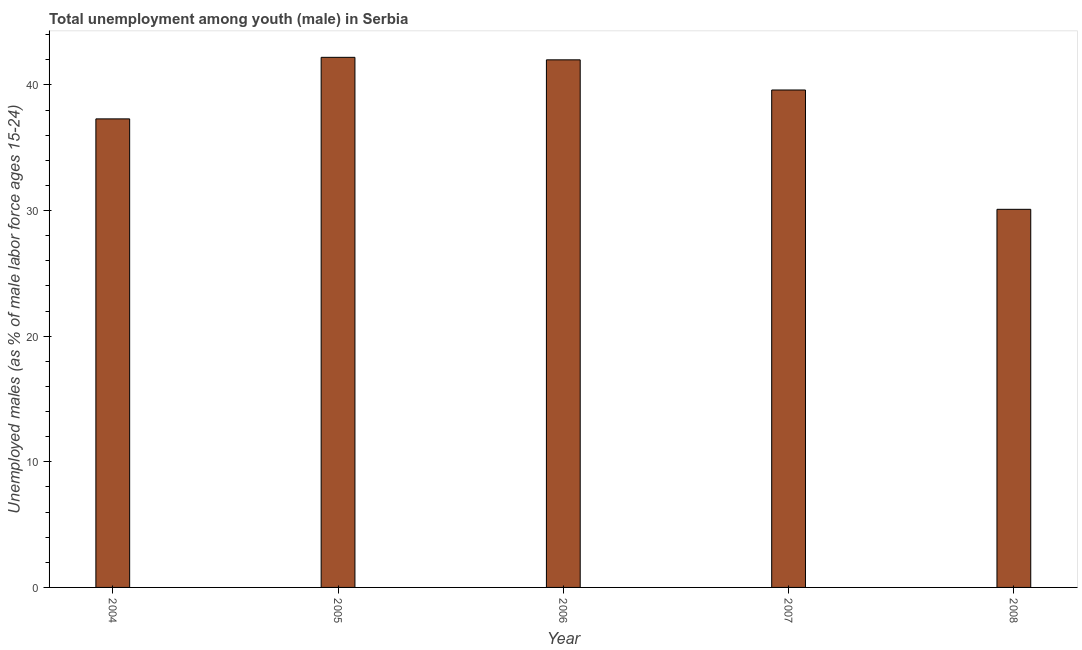Does the graph contain any zero values?
Ensure brevity in your answer.  No. What is the title of the graph?
Provide a short and direct response. Total unemployment among youth (male) in Serbia. What is the label or title of the Y-axis?
Provide a succinct answer. Unemployed males (as % of male labor force ages 15-24). What is the unemployed male youth population in 2008?
Give a very brief answer. 30.1. Across all years, what is the maximum unemployed male youth population?
Give a very brief answer. 42.2. Across all years, what is the minimum unemployed male youth population?
Give a very brief answer. 30.1. In which year was the unemployed male youth population maximum?
Give a very brief answer. 2005. What is the sum of the unemployed male youth population?
Ensure brevity in your answer.  191.2. What is the difference between the unemployed male youth population in 2004 and 2007?
Make the answer very short. -2.3. What is the average unemployed male youth population per year?
Your response must be concise. 38.24. What is the median unemployed male youth population?
Your response must be concise. 39.6. What is the ratio of the unemployed male youth population in 2004 to that in 2006?
Give a very brief answer. 0.89. Is the difference between the unemployed male youth population in 2004 and 2007 greater than the difference between any two years?
Offer a terse response. No. What is the difference between the highest and the second highest unemployed male youth population?
Keep it short and to the point. 0.2. Is the sum of the unemployed male youth population in 2005 and 2006 greater than the maximum unemployed male youth population across all years?
Keep it short and to the point. Yes. In how many years, is the unemployed male youth population greater than the average unemployed male youth population taken over all years?
Your answer should be compact. 3. How many bars are there?
Your answer should be very brief. 5. Are the values on the major ticks of Y-axis written in scientific E-notation?
Keep it short and to the point. No. What is the Unemployed males (as % of male labor force ages 15-24) in 2004?
Provide a succinct answer. 37.3. What is the Unemployed males (as % of male labor force ages 15-24) of 2005?
Your answer should be compact. 42.2. What is the Unemployed males (as % of male labor force ages 15-24) in 2007?
Offer a terse response. 39.6. What is the Unemployed males (as % of male labor force ages 15-24) of 2008?
Ensure brevity in your answer.  30.1. What is the difference between the Unemployed males (as % of male labor force ages 15-24) in 2004 and 2007?
Make the answer very short. -2.3. What is the ratio of the Unemployed males (as % of male labor force ages 15-24) in 2004 to that in 2005?
Give a very brief answer. 0.88. What is the ratio of the Unemployed males (as % of male labor force ages 15-24) in 2004 to that in 2006?
Your response must be concise. 0.89. What is the ratio of the Unemployed males (as % of male labor force ages 15-24) in 2004 to that in 2007?
Give a very brief answer. 0.94. What is the ratio of the Unemployed males (as % of male labor force ages 15-24) in 2004 to that in 2008?
Give a very brief answer. 1.24. What is the ratio of the Unemployed males (as % of male labor force ages 15-24) in 2005 to that in 2006?
Give a very brief answer. 1. What is the ratio of the Unemployed males (as % of male labor force ages 15-24) in 2005 to that in 2007?
Make the answer very short. 1.07. What is the ratio of the Unemployed males (as % of male labor force ages 15-24) in 2005 to that in 2008?
Give a very brief answer. 1.4. What is the ratio of the Unemployed males (as % of male labor force ages 15-24) in 2006 to that in 2007?
Make the answer very short. 1.06. What is the ratio of the Unemployed males (as % of male labor force ages 15-24) in 2006 to that in 2008?
Offer a terse response. 1.4. What is the ratio of the Unemployed males (as % of male labor force ages 15-24) in 2007 to that in 2008?
Ensure brevity in your answer.  1.32. 